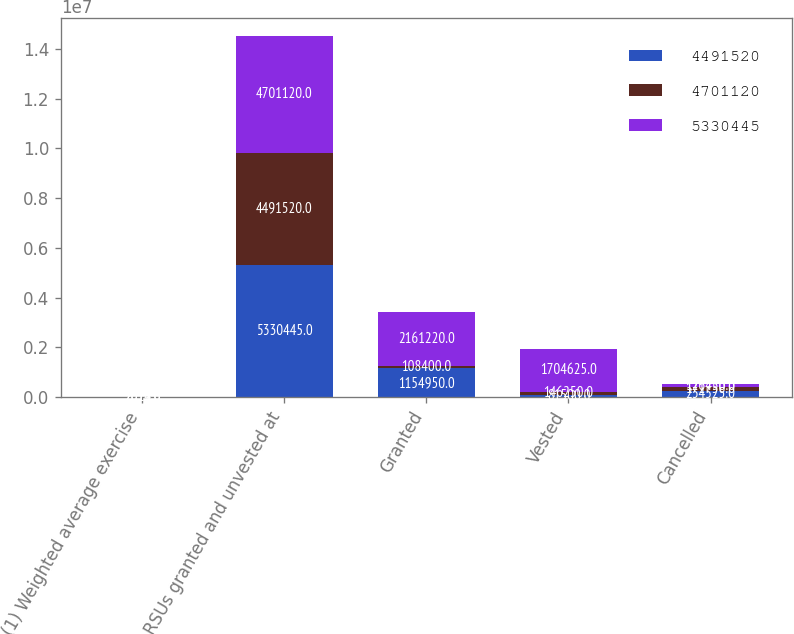<chart> <loc_0><loc_0><loc_500><loc_500><stacked_bar_chart><ecel><fcel>(1) Weighted average exercise<fcel>RSUs granted and unvested at<fcel>Granted<fcel>Vested<fcel>Cancelled<nl><fcel>4.49152e+06<fcel>2014<fcel>5.33044e+06<fcel>1.15495e+06<fcel>81500<fcel>234525<nl><fcel>4.70112e+06<fcel>2013<fcel>4.49152e+06<fcel>108400<fcel>146250<fcel>171750<nl><fcel>5.33044e+06<fcel>2012<fcel>4.70112e+06<fcel>2.16122e+06<fcel>1.70462e+06<fcel>126450<nl></chart> 